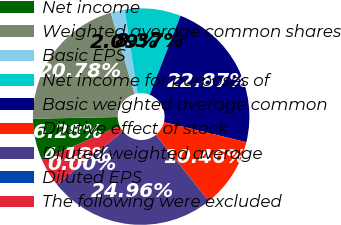Convert chart. <chart><loc_0><loc_0><loc_500><loc_500><pie_chart><fcel>Net income<fcel>Weighted average common shares<fcel>Basic EPS<fcel>Net income for purposes of<fcel>Basic weighted average common<fcel>Dilutive effect of stock<fcel>Diluted weighted average<fcel>Diluted EPS<fcel>The following were excluded<nl><fcel>6.28%<fcel>20.78%<fcel>2.09%<fcel>8.37%<fcel>22.87%<fcel>10.46%<fcel>24.96%<fcel>0.0%<fcel>4.18%<nl></chart> 